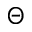<formula> <loc_0><loc_0><loc_500><loc_500>\Theta</formula> 